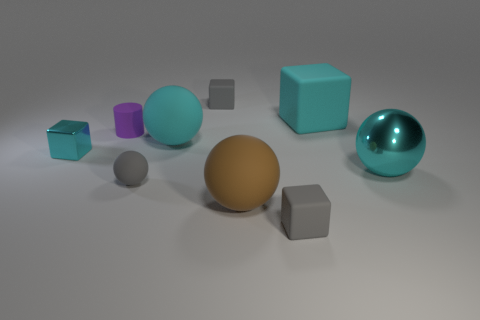There is a gray sphere; is its size the same as the cyan matte thing that is in front of the large rubber cube?
Provide a short and direct response. No. There is a shiny thing that is in front of the tiny cube to the left of the small gray matte object behind the tiny cyan metallic block; what size is it?
Provide a succinct answer. Large. What material is the small cyan cube?
Your answer should be compact. Metal. There is a cyan ball that is behind the small cyan metallic object; how many gray rubber cubes are behind it?
Your answer should be very brief. 1. There is a cyan cube that is the same size as the purple matte cylinder; what is its material?
Your answer should be compact. Metal. What number of other objects are there of the same material as the big cyan block?
Ensure brevity in your answer.  6. There is a purple rubber cylinder; how many tiny matte blocks are in front of it?
Your answer should be very brief. 1. How many cylinders are small rubber objects or purple things?
Provide a succinct answer. 1. There is a cyan thing that is both left of the brown ball and right of the small purple rubber cylinder; how big is it?
Ensure brevity in your answer.  Large. How many other things are the same color as the matte cylinder?
Your answer should be compact. 0. 